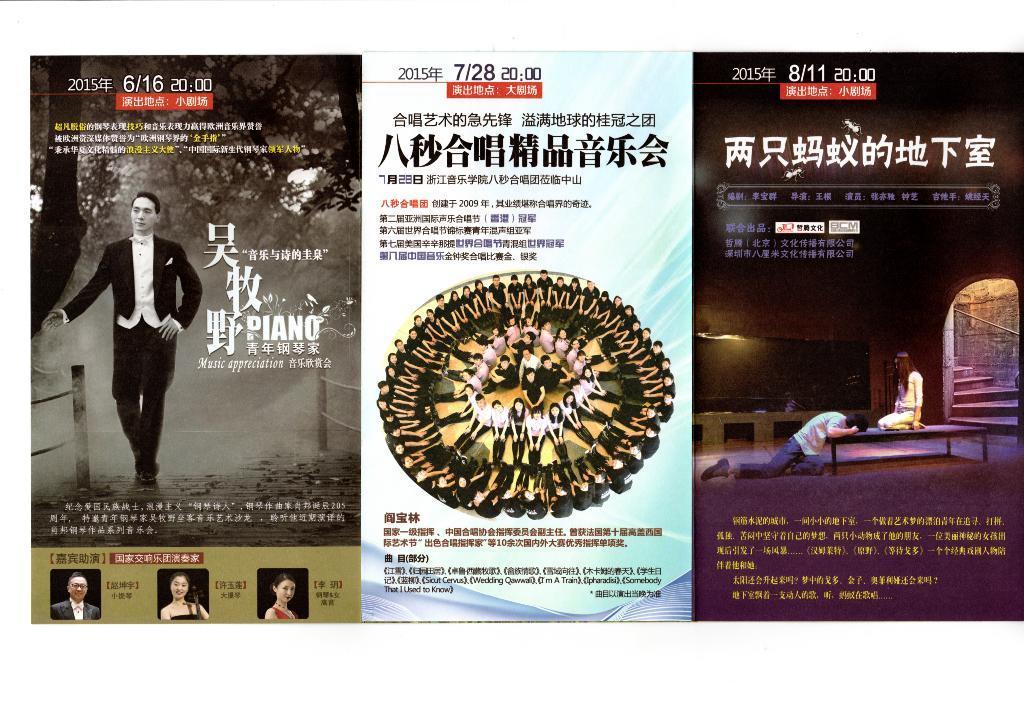Could you give a brief overview of what you see in this image? In the image we can see there are three posters. In the left poster we can see a person standing, wearing clothes and shoes, we can even see trees. In the middle image we can see there are many people sitting, in circular shape. In the right poster we can see a man and a wearing clothes and these are stairs. 